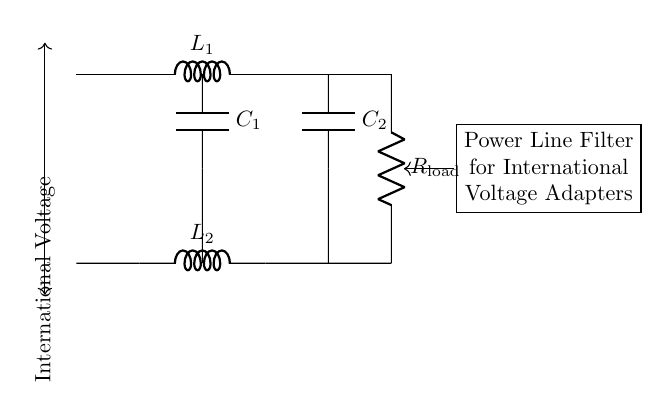What is the component labeled L1? The component labeled L1 is an inductor, which is a passive electrical component that stores energy in a magnetic field when electric current flows through it.
Answer: Inductor What does C1 represent in the circuit? C1 represents a capacitor, which is used to store electrical energy temporarily and smooth out voltage fluctuations in the circuit.
Answer: Capacitor How many inductors are present in the circuit? There are two inductors present in the circuit, L1 and L2, as indicated by the labels on the diagram.
Answer: Two What is the role of the filter in this circuit? The filter's role is to remove unwanted frequencies from the power line, ensuring that the electrical supply remains stable and free of interference, especially for international voltage adapters.
Answer: Remove unwanted frequencies If the load resistance is labeled R_load, what can be assumed about its role in the circuit? The load resistance R_load represents the component that consumes power in the circuit; it converts electrical energy into another form of energy, such as heat or light, and determines how the circuit operates under different conditions.
Answer: Consumes power What do the capacitors C1 and C2 likely do together? Together, capacitors C1 and C2 work to filter input voltage by blocking direct current (DC) while allowing alternating current (AC) signals to pass through, reducing ripple in the output voltage.
Answer: Filter input voltage What is the significance of the arrow labeled "International Voltage"? The arrow labeled "International Voltage" indicates the input side of the circuit that is designed to accommodate various voltage levels found in different countries, showing that this circuit is versatile for international use.
Answer: Versatile for international use 